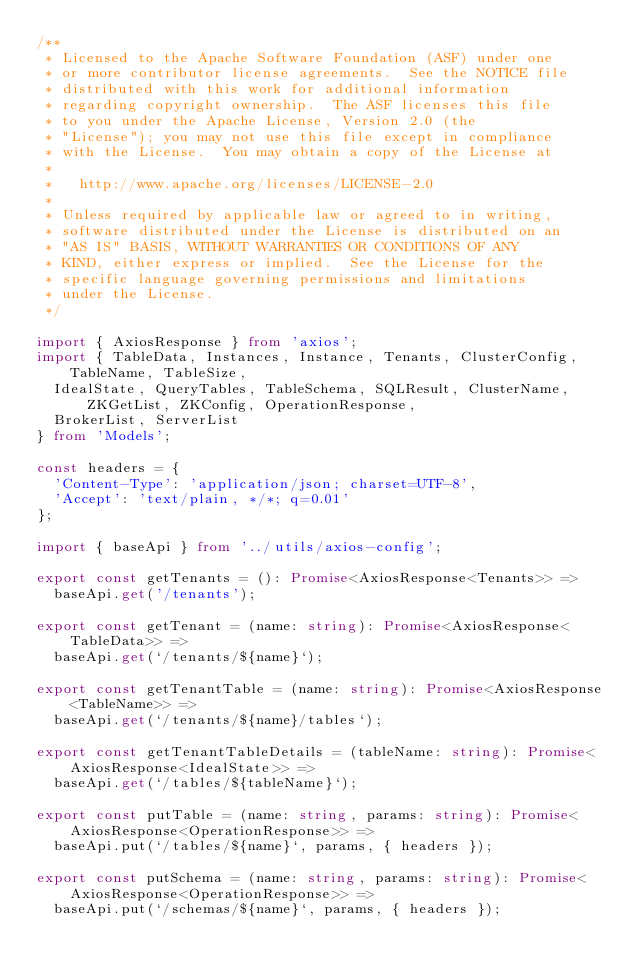<code> <loc_0><loc_0><loc_500><loc_500><_TypeScript_>/**
 * Licensed to the Apache Software Foundation (ASF) under one
 * or more contributor license agreements.  See the NOTICE file
 * distributed with this work for additional information
 * regarding copyright ownership.  The ASF licenses this file
 * to you under the Apache License, Version 2.0 (the
 * "License"); you may not use this file except in compliance
 * with the License.  You may obtain a copy of the License at
 *
 *   http://www.apache.org/licenses/LICENSE-2.0
 *
 * Unless required by applicable law or agreed to in writing,
 * software distributed under the License is distributed on an
 * "AS IS" BASIS, WITHOUT WARRANTIES OR CONDITIONS OF ANY
 * KIND, either express or implied.  See the License for the
 * specific language governing permissions and limitations
 * under the License.
 */

import { AxiosResponse } from 'axios';
import { TableData, Instances, Instance, Tenants, ClusterConfig, TableName, TableSize,
  IdealState, QueryTables, TableSchema, SQLResult, ClusterName, ZKGetList, ZKConfig, OperationResponse,
  BrokerList, ServerList
} from 'Models';

const headers = {
  'Content-Type': 'application/json; charset=UTF-8',
  'Accept': 'text/plain, */*; q=0.01'
};

import { baseApi } from '../utils/axios-config';

export const getTenants = (): Promise<AxiosResponse<Tenants>> =>
  baseApi.get('/tenants');

export const getTenant = (name: string): Promise<AxiosResponse<TableData>> =>
  baseApi.get(`/tenants/${name}`);

export const getTenantTable = (name: string): Promise<AxiosResponse<TableName>> =>
  baseApi.get(`/tenants/${name}/tables`);

export const getTenantTableDetails = (tableName: string): Promise<AxiosResponse<IdealState>> =>
  baseApi.get(`/tables/${tableName}`);

export const putTable = (name: string, params: string): Promise<AxiosResponse<OperationResponse>> =>
  baseApi.put(`/tables/${name}`, params, { headers });

export const putSchema = (name: string, params: string): Promise<AxiosResponse<OperationResponse>> =>
  baseApi.put(`/schemas/${name}`, params, { headers });
</code> 